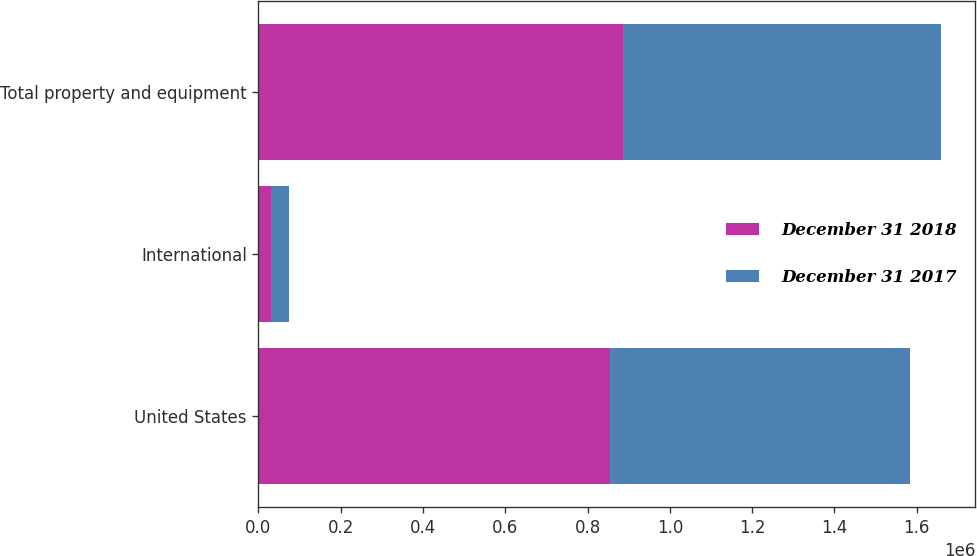Convert chart. <chart><loc_0><loc_0><loc_500><loc_500><stacked_bar_chart><ecel><fcel>United States<fcel>International<fcel>Total property and equipment<nl><fcel>December 31 2018<fcel>853731<fcel>31347<fcel>885078<nl><fcel>December 31 2017<fcel>730262<fcel>43453<fcel>773715<nl></chart> 